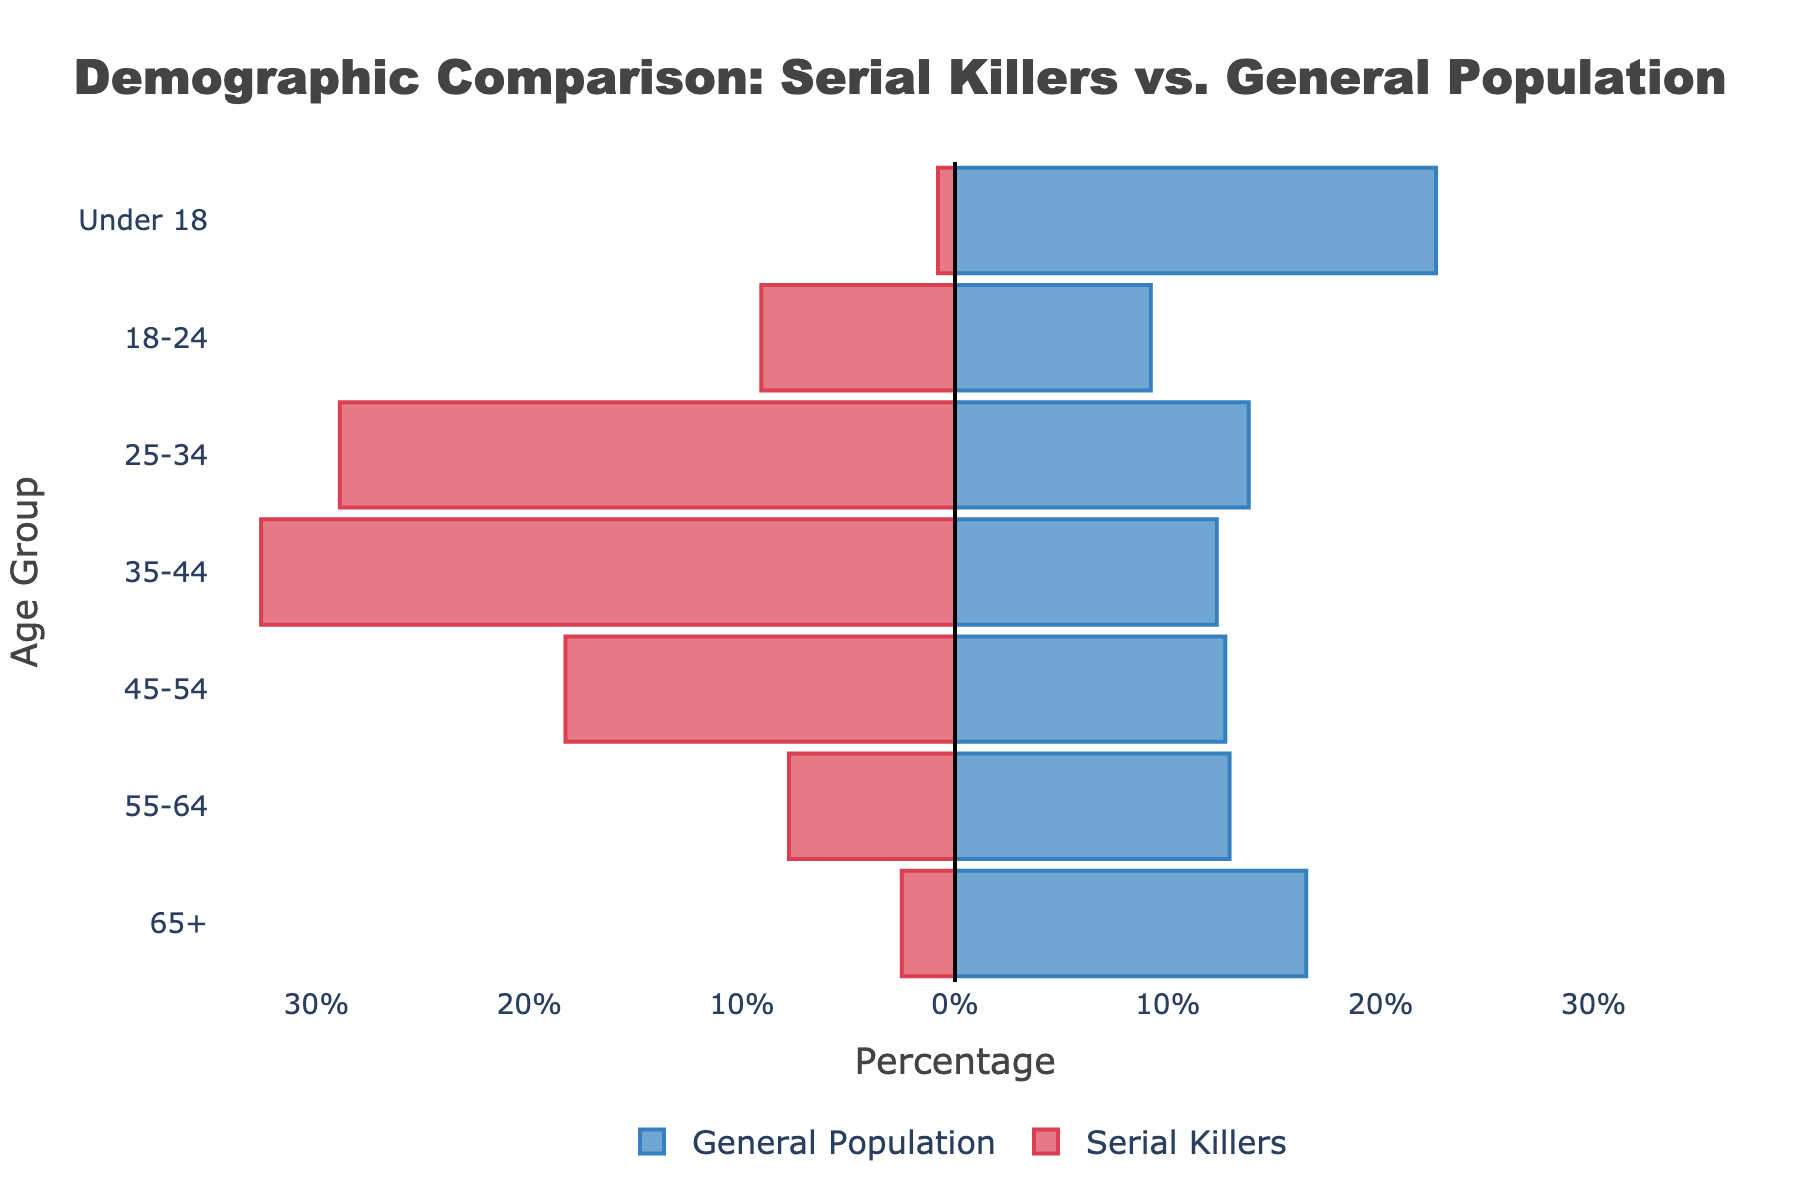What is the title of the figure? The title is prominently displayed at the top of the figure. It reads: "Demographic Comparison: Serial Killers vs. General Population".
Answer: Demographic Comparison: Serial Killers vs. General Population Which age group has the highest percentage of serial killers? By looking at the bars for Serial Killers, the age group 35-44 has the longest red bar on the negative side of the x-axis, indicating the highest percentage.
Answer: 35-44 How does the percentage of serial killers in the age group 25-34 compare to the general population in the same age group? The figure shows the bar for serial killers in the age group 25-34 is longer than that for the general population. Serial Killers stand at 28.9%, while the General Population is at 13.8%.
Answer: Higher What is the combined percentage of serial killers in the age groups 45-54 and 35-44? Summing up the percentages of serial killers in the age groups 45-54 and 35-44, we get 18.3% + 32.6% = 50.9%.
Answer: 50.9% Which age group exhibits the most significant discrepancy between the serial killers' percentage and the general population's percentage? By visually comparing the differences between the bars for each age group, the age group 'Under 18' shows the most significant gap with serial killers at 0.8% and the general population at 22.6%.
Answer: Under 18 Are there any age groups where the percentage of serial killers is nearly equal to the general population? Observing the bars, the age group 18-24 has nearly equal percentages; Serial Killers are at 9.1%, and the General Population is 9.2%.
Answer: 18-24 How much higher is the percentage of the general population in the age group 65+ compared to serial killers? Subtract the percentage of serial killers from the percentage of the general population in the age group 65+: 16.5% - 2.5% = 14%. The general population is 14% higher in this age group.
Answer: 14% What is the approximate percentage difference between serial killers and the general population in the 35-44 age group? Subtract the percentage of the general population from the percentage of serial killers in the 35-44 age group: 32.6% - 12.3% = 20.3%.
Answer: 20.3% Which age group has the lowest representation of serial killers? The shortest red bar on the negative side of the x-axis represents this. The age group Under 18 has the lowest representation at 0.8%.
Answer: Under 18 